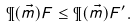Convert formula to latex. <formula><loc_0><loc_0><loc_500><loc_500>\P ( \vec { m } ) F \leq \P ( \vec { m } ) F ^ { \prime } .</formula> 